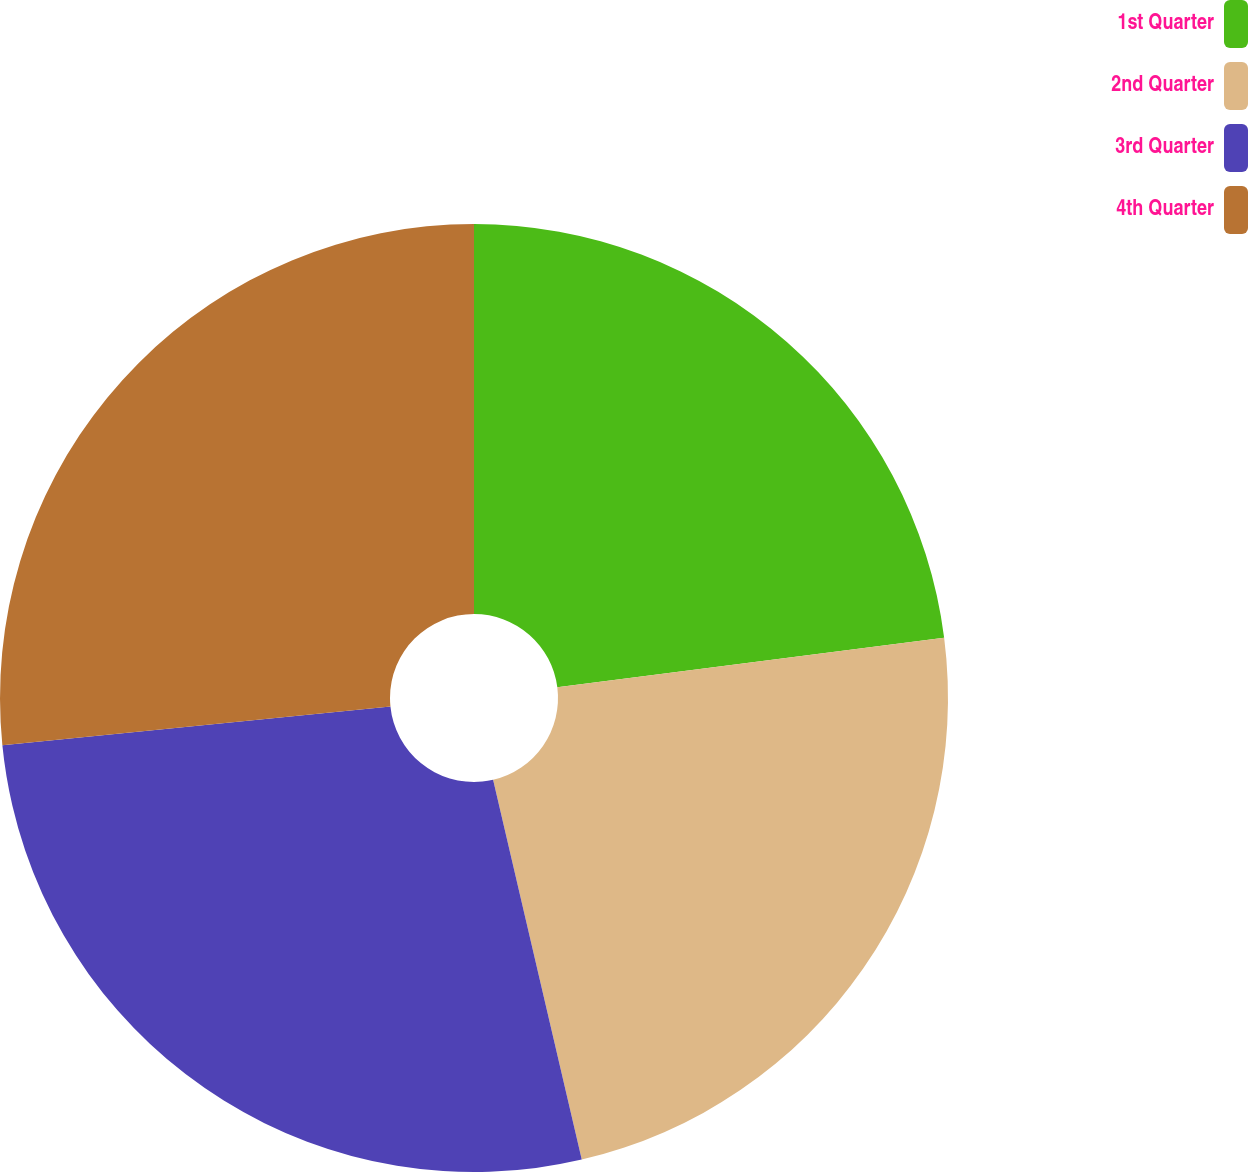Convert chart. <chart><loc_0><loc_0><loc_500><loc_500><pie_chart><fcel>1st Quarter<fcel>2nd Quarter<fcel>3rd Quarter<fcel>4th Quarter<nl><fcel>22.97%<fcel>23.38%<fcel>27.06%<fcel>26.59%<nl></chart> 